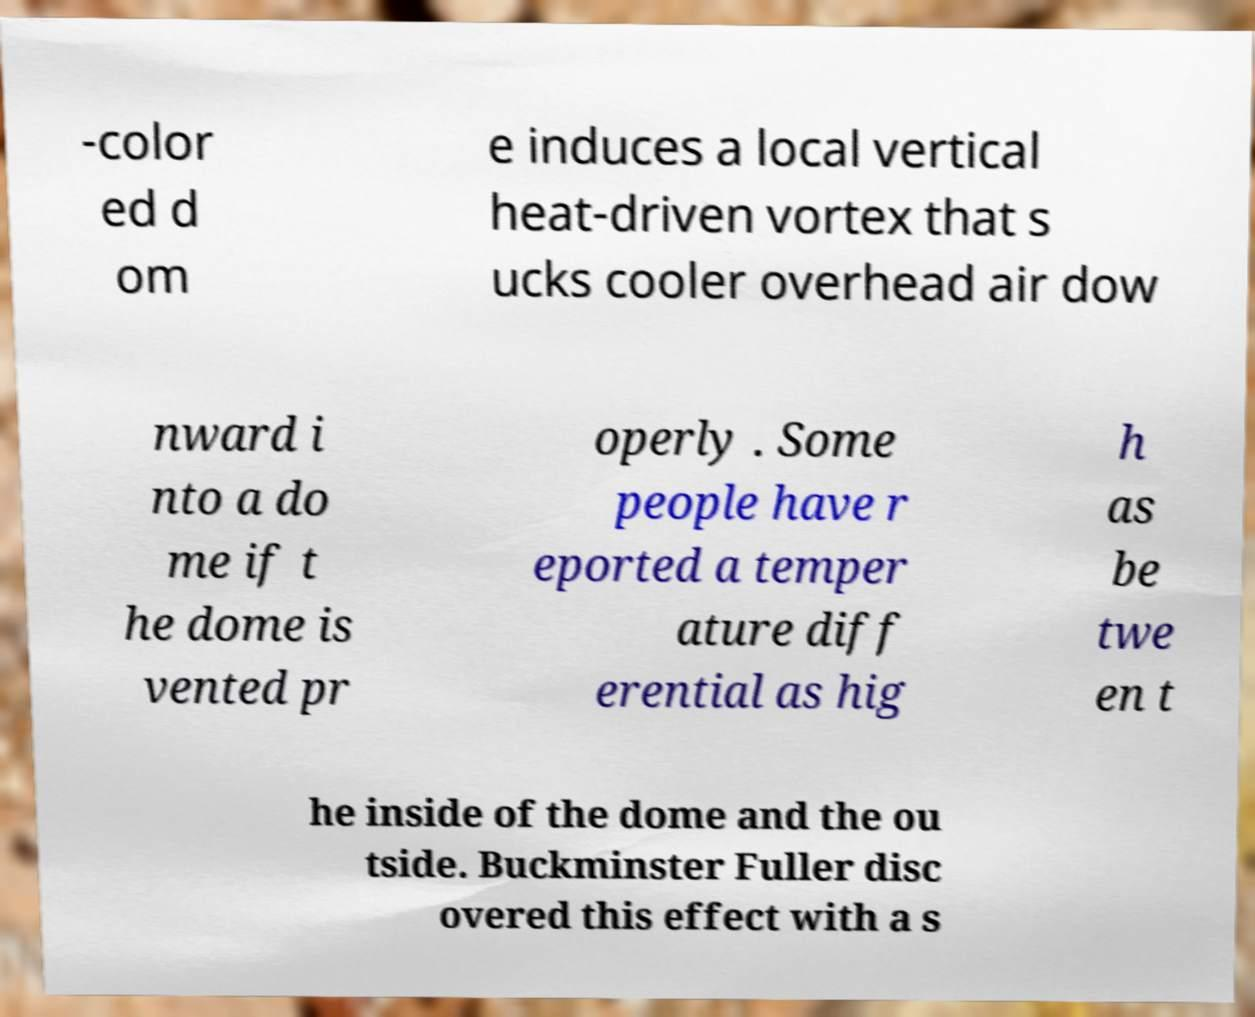Please read and relay the text visible in this image. What does it say? -color ed d om e induces a local vertical heat-driven vortex that s ucks cooler overhead air dow nward i nto a do me if t he dome is vented pr operly . Some people have r eported a temper ature diff erential as hig h as be twe en t he inside of the dome and the ou tside. Buckminster Fuller disc overed this effect with a s 